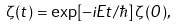<formula> <loc_0><loc_0><loc_500><loc_500>\zeta ( t ) = \exp [ - i E t / \hbar { ] } \, \zeta ( 0 ) ,</formula> 